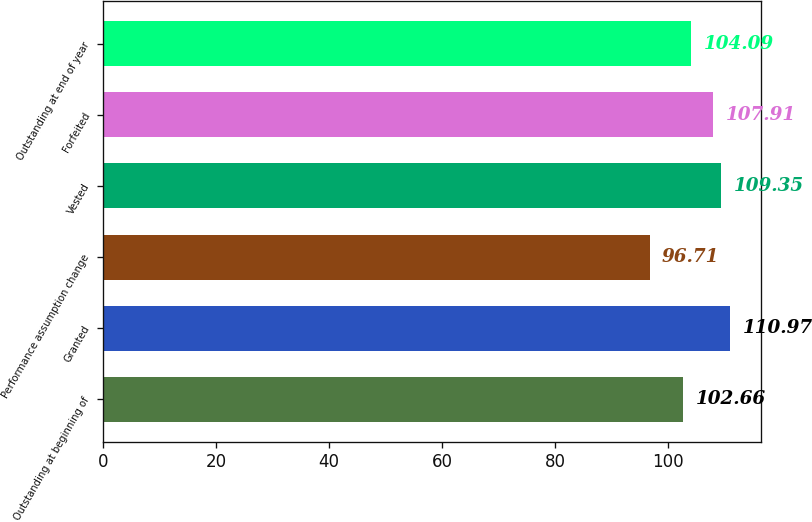<chart> <loc_0><loc_0><loc_500><loc_500><bar_chart><fcel>Outstanding at beginning of<fcel>Granted<fcel>Performance assumption change<fcel>Vested<fcel>Forfeited<fcel>Outstanding at end of year<nl><fcel>102.66<fcel>110.97<fcel>96.71<fcel>109.35<fcel>107.91<fcel>104.09<nl></chart> 